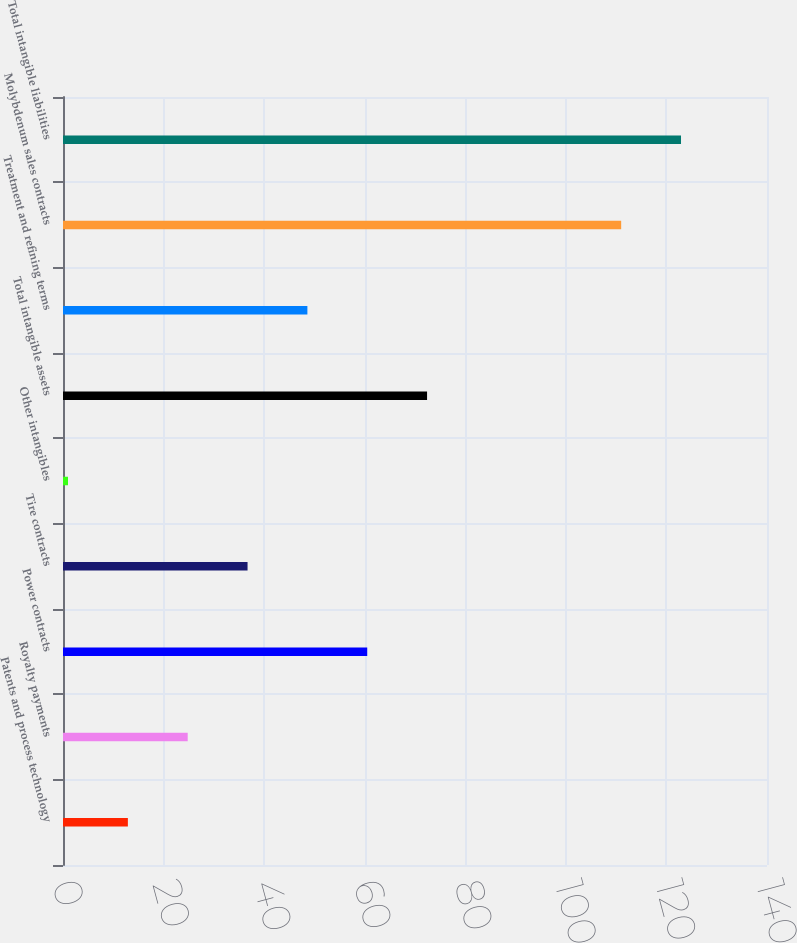Convert chart. <chart><loc_0><loc_0><loc_500><loc_500><bar_chart><fcel>Patents and process technology<fcel>Royalty payments<fcel>Power contracts<fcel>Tire contracts<fcel>Other intangibles<fcel>Total intangible assets<fcel>Treatment and refining terms<fcel>Molybdenum sales contracts<fcel>Total intangible liabilities<nl><fcel>12.9<fcel>24.8<fcel>60.5<fcel>36.7<fcel>1<fcel>72.4<fcel>48.6<fcel>111<fcel>122.9<nl></chart> 